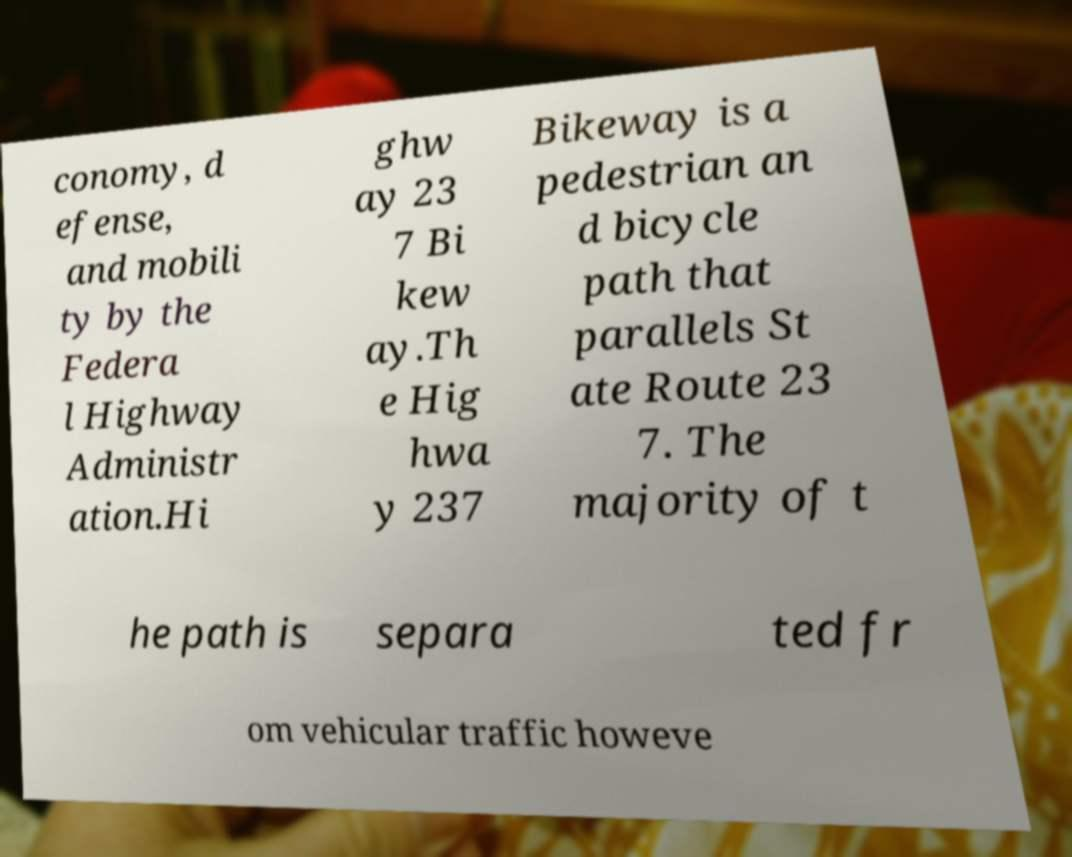What messages or text are displayed in this image? I need them in a readable, typed format. conomy, d efense, and mobili ty by the Federa l Highway Administr ation.Hi ghw ay 23 7 Bi kew ay.Th e Hig hwa y 237 Bikeway is a pedestrian an d bicycle path that parallels St ate Route 23 7. The majority of t he path is separa ted fr om vehicular traffic howeve 